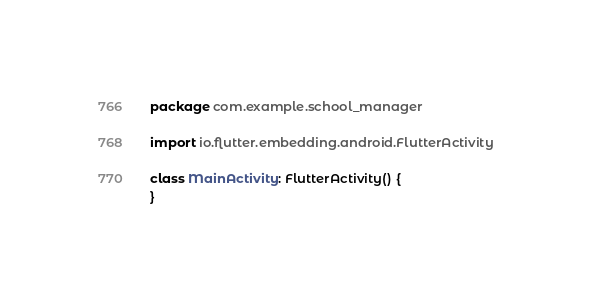<code> <loc_0><loc_0><loc_500><loc_500><_Kotlin_>package com.example.school_manager

import io.flutter.embedding.android.FlutterActivity

class MainActivity: FlutterActivity() {
}
</code> 